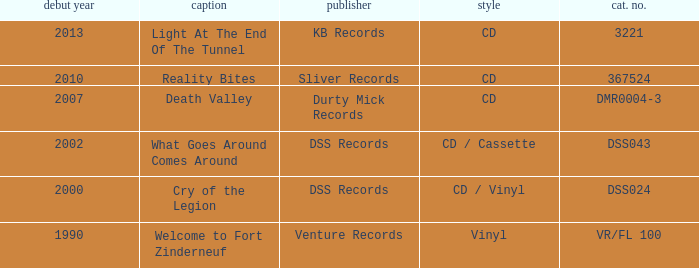What is the total year of release of the title what goes around comes around? 1.0. 